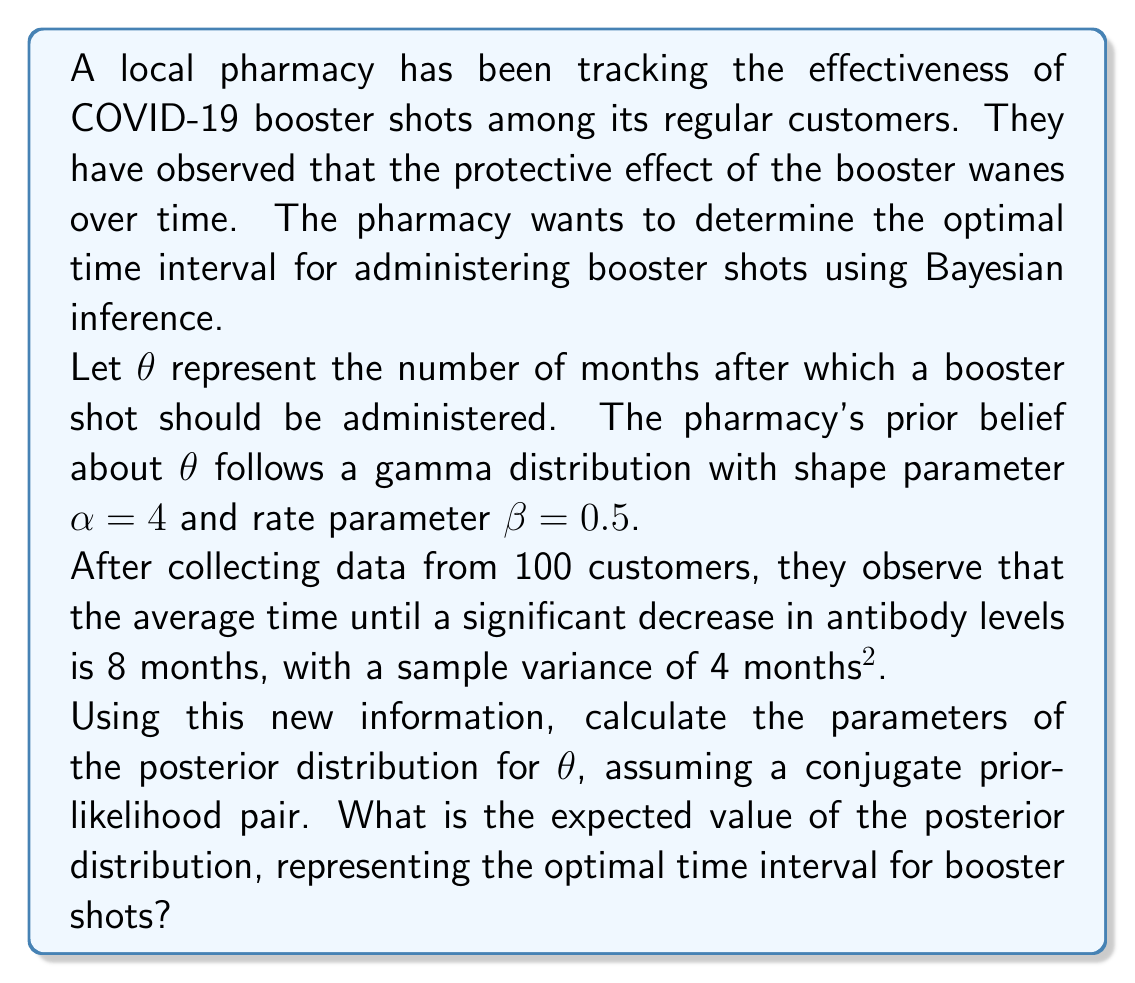Can you answer this question? To solve this problem, we'll use Bayesian inference with a gamma prior and a normal likelihood. The steps are as follows:

1) Prior distribution:
   $\theta \sim \text{Gamma}(\alpha, \beta)$ with $\alpha = 4$ and $\beta = 0.5$

2) Likelihood:
   We assume the data follows a normal distribution with unknown mean $\theta$ and known variance $\sigma^2 = 4$. The sample mean is $\bar{x} = 8$ and sample size $n = 100$.

3) Posterior distribution:
   For a gamma prior and normal likelihood with known variance, the posterior distribution is also gamma. The updated parameters are:

   $$\alpha_{post} = \alpha + \frac{n}{2} = 4 + \frac{100}{2} = 54$$

   $$\beta_{post} = \beta + \frac{n}{2\sigma^2}(\bar{x} - \mu)^2 + \frac{n}{2\sigma^2}$$

   Where $\mu = \frac{\alpha}{\beta} = \frac{4}{0.5} = 8$ (prior mean)

   $$\beta_{post} = 0.5 + \frac{100}{2(4)}(8 - 8)^2 + \frac{100}{2(4)} = 0.5 + 0 + 12.5 = 13$$

4) Expected value of the posterior distribution:
   For a gamma distribution, the expected value is $E[\theta] = \frac{\alpha_{post}}{\beta_{post}}$

   $$E[\theta] = \frac{54}{13} \approx 4.15$$

Therefore, the optimal time interval for booster shots based on this Bayesian analysis is approximately 4.15 months.
Answer: The optimal time interval for booster shots is approximately 4.15 months. 